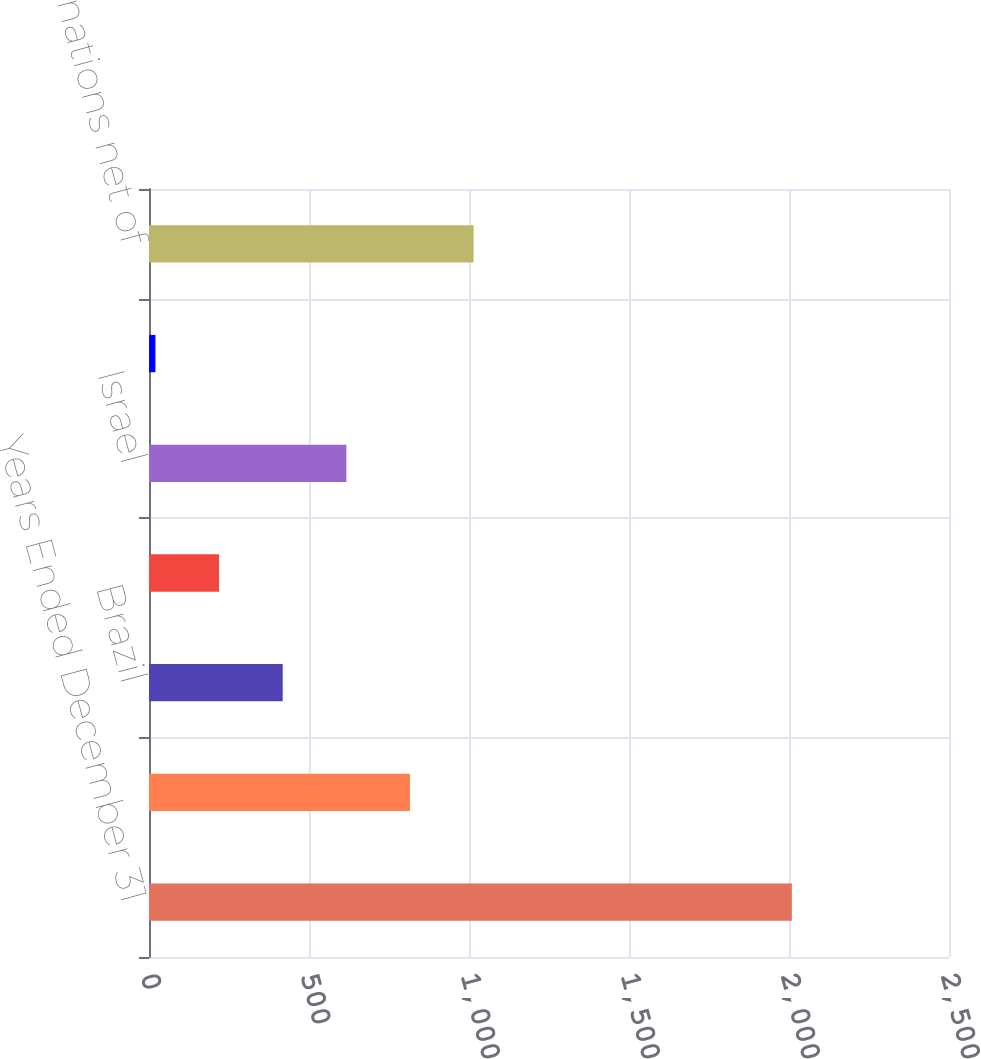Convert chart to OTSL. <chart><loc_0><loc_0><loc_500><loc_500><bar_chart><fcel>Years Ended December 31<fcel>China<fcel>Brazil<fcel>United Kingdom<fcel>Israel<fcel>Singapore<fcel>Other nations net of<nl><fcel>2009<fcel>815.6<fcel>417.8<fcel>218.9<fcel>616.7<fcel>20<fcel>1014.5<nl></chart> 